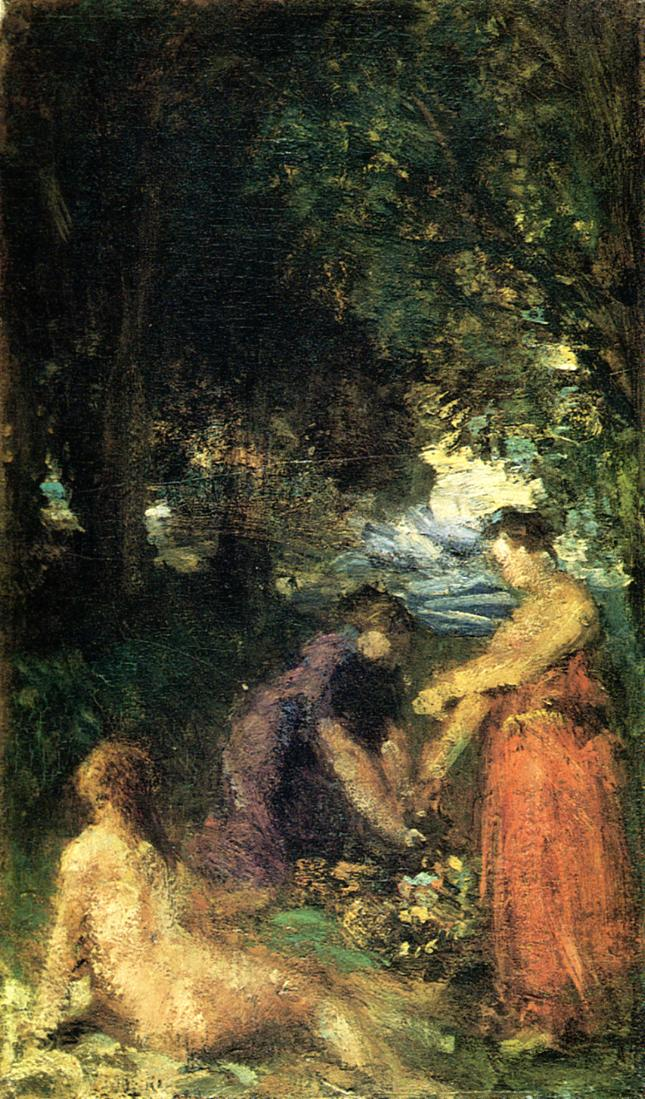Can you describe the mood and atmosphere of this painting in more detail? The mood of this painting is serene and reflective. The earthy tones and soft brushstrokes evoke a sense of calmness and tranquility. The dappled light filtering through the forest canopy creates a gentle, soothing ambiance, as if the viewer can feel the cool, refreshing air of the woods. The figures, engaged in quiet activities, contribute to the peaceful atmosphere, suggesting a sense of community and shared solitude. The small patch of sky adds a hopeful, uplifting element, balancing the shadows of the dense foliage with a touch of light and openness. 